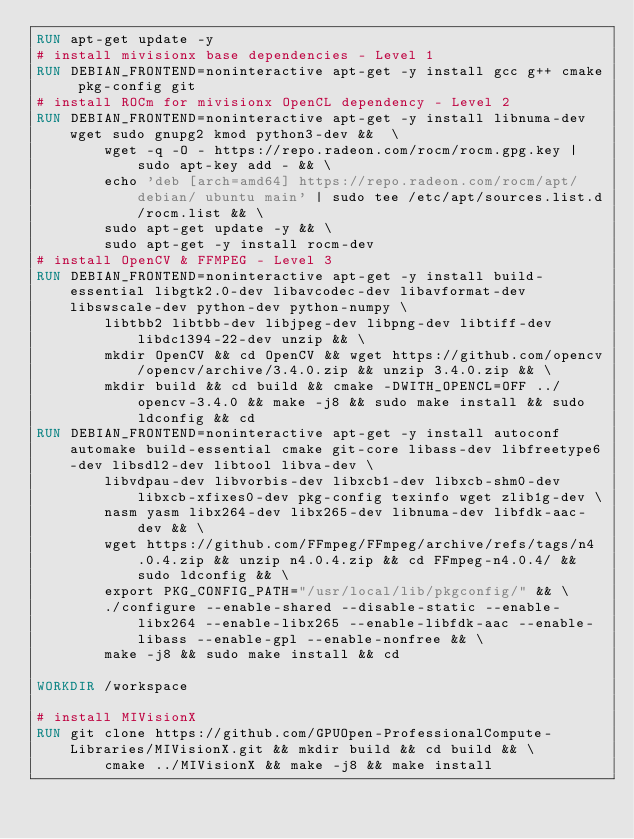<code> <loc_0><loc_0><loc_500><loc_500><_Dockerfile_>RUN apt-get update -y
# install mivisionx base dependencies - Level 1
RUN DEBIAN_FRONTEND=noninteractive apt-get -y install gcc g++ cmake pkg-config git
# install ROCm for mivisionx OpenCL dependency - Level 2
RUN DEBIAN_FRONTEND=noninteractive apt-get -y install libnuma-dev wget sudo gnupg2 kmod python3-dev &&  \
        wget -q -O - https://repo.radeon.com/rocm/rocm.gpg.key | sudo apt-key add - && \
        echo 'deb [arch=amd64] https://repo.radeon.com/rocm/apt/debian/ ubuntu main' | sudo tee /etc/apt/sources.list.d/rocm.list && \
        sudo apt-get update -y && \
        sudo apt-get -y install rocm-dev
# install OpenCV & FFMPEG - Level 3
RUN DEBIAN_FRONTEND=noninteractive apt-get -y install build-essential libgtk2.0-dev libavcodec-dev libavformat-dev libswscale-dev python-dev python-numpy \
        libtbb2 libtbb-dev libjpeg-dev libpng-dev libtiff-dev libdc1394-22-dev unzip && \
        mkdir OpenCV && cd OpenCV && wget https://github.com/opencv/opencv/archive/3.4.0.zip && unzip 3.4.0.zip && \
        mkdir build && cd build && cmake -DWITH_OPENCL=OFF ../opencv-3.4.0 && make -j8 && sudo make install && sudo ldconfig && cd
RUN DEBIAN_FRONTEND=noninteractive apt-get -y install autoconf automake build-essential cmake git-core libass-dev libfreetype6-dev libsdl2-dev libtool libva-dev \
        libvdpau-dev libvorbis-dev libxcb1-dev libxcb-shm0-dev libxcb-xfixes0-dev pkg-config texinfo wget zlib1g-dev \
        nasm yasm libx264-dev libx265-dev libnuma-dev libfdk-aac-dev && \
        wget https://github.com/FFmpeg/FFmpeg/archive/refs/tags/n4.0.4.zip && unzip n4.0.4.zip && cd FFmpeg-n4.0.4/ && sudo ldconfig && \
        export PKG_CONFIG_PATH="/usr/local/lib/pkgconfig/" && \
        ./configure --enable-shared --disable-static --enable-libx264 --enable-libx265 --enable-libfdk-aac --enable-libass --enable-gpl --enable-nonfree && \
        make -j8 && sudo make install && cd

WORKDIR /workspace

# install MIVisionX
RUN git clone https://github.com/GPUOpen-ProfessionalCompute-Libraries/MIVisionX.git && mkdir build && cd build && \
        cmake ../MIVisionX && make -j8 && make install</code> 